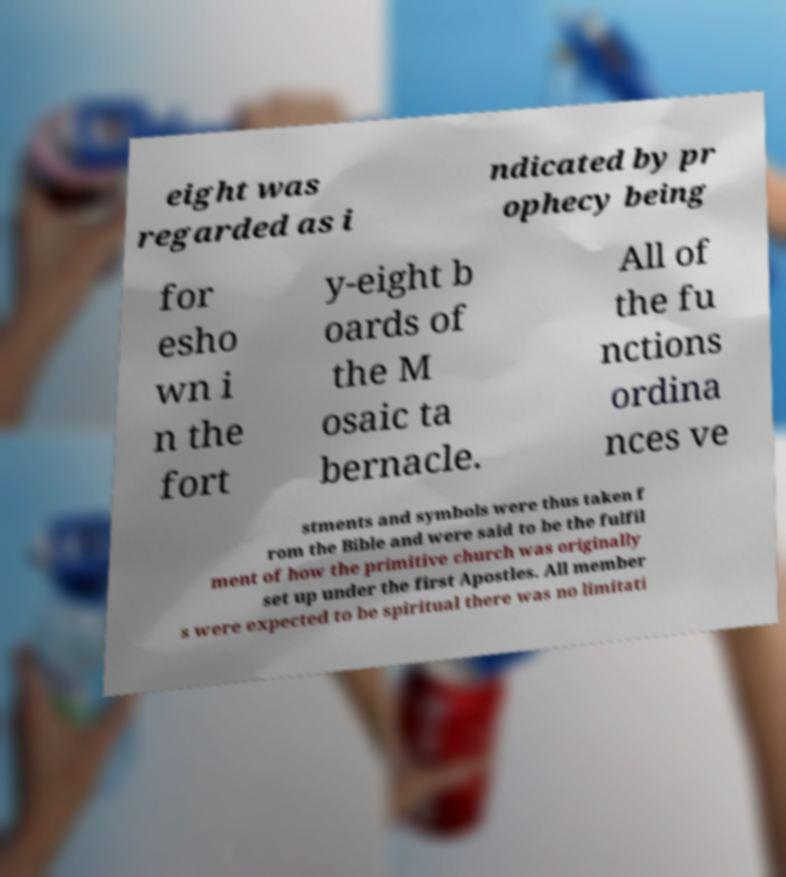Please read and relay the text visible in this image. What does it say? eight was regarded as i ndicated by pr ophecy being for esho wn i n the fort y-eight b oards of the M osaic ta bernacle. All of the fu nctions ordina nces ve stments and symbols were thus taken f rom the Bible and were said to be the fulfil ment of how the primitive church was originally set up under the first Apostles. All member s were expected to be spiritual there was no limitati 